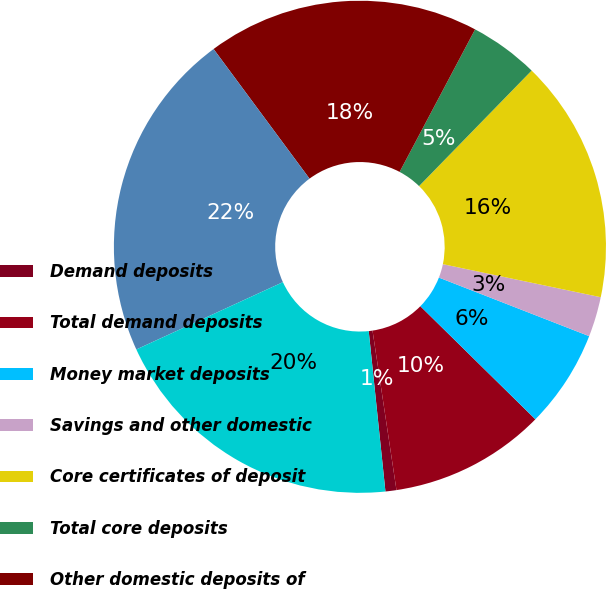<chart> <loc_0><loc_0><loc_500><loc_500><pie_chart><fcel>Demand deposits<fcel>Total demand deposits<fcel>Money market deposits<fcel>Savings and other domestic<fcel>Core certificates of deposit<fcel>Total core deposits<fcel>Other domestic deposits of<fcel>Brokered deposits and<fcel>Deposits in foreign offices<nl><fcel>0.72%<fcel>10.26%<fcel>6.45%<fcel>2.63%<fcel>15.99%<fcel>4.54%<fcel>17.89%<fcel>21.71%<fcel>19.8%<nl></chart> 